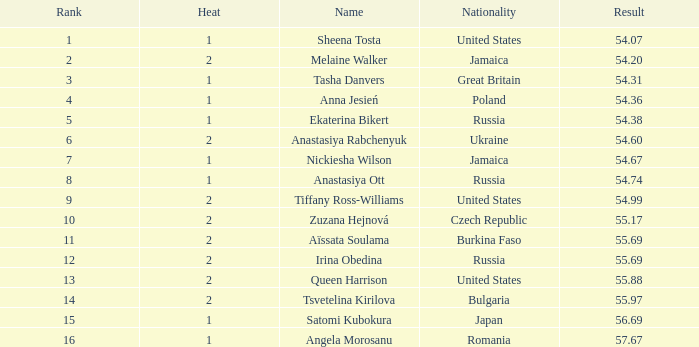Which Rank has a Name of tsvetelina kirilova, and a Result smaller than 55.97? None. 